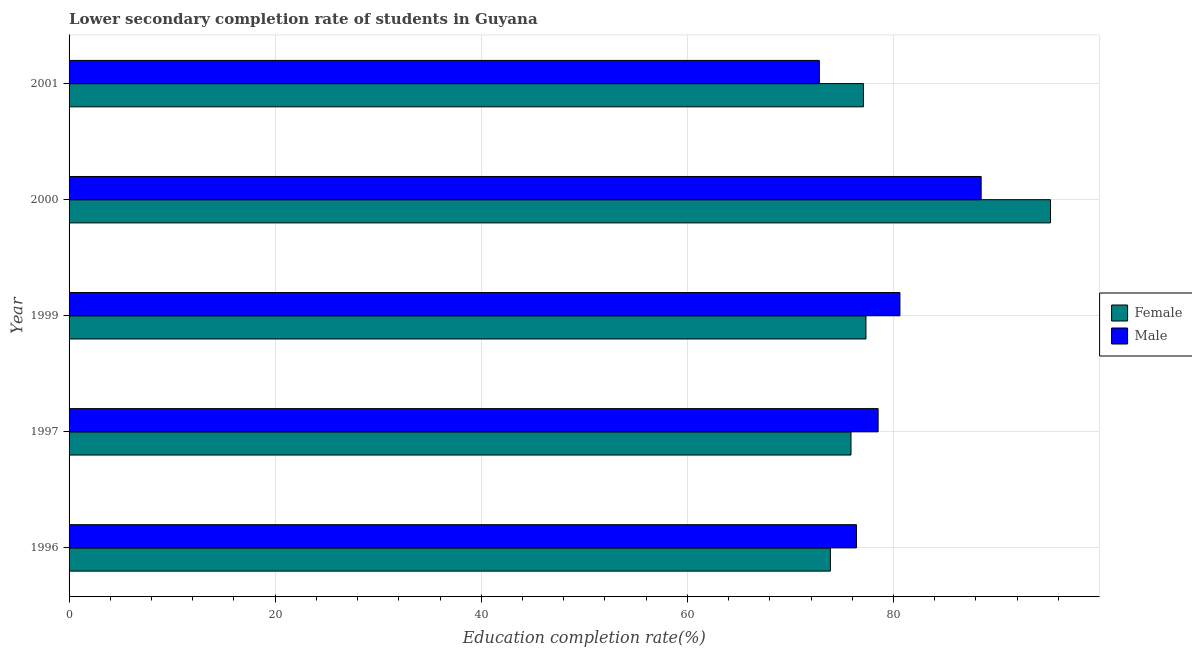How many groups of bars are there?
Offer a terse response. 5. Are the number of bars per tick equal to the number of legend labels?
Keep it short and to the point. Yes. In how many cases, is the number of bars for a given year not equal to the number of legend labels?
Your response must be concise. 0. What is the education completion rate of male students in 2001?
Keep it short and to the point. 72.8. Across all years, what is the maximum education completion rate of female students?
Make the answer very short. 95.24. Across all years, what is the minimum education completion rate of female students?
Your answer should be very brief. 73.87. In which year was the education completion rate of male students maximum?
Offer a very short reply. 2000. In which year was the education completion rate of female students minimum?
Offer a very short reply. 1996. What is the total education completion rate of male students in the graph?
Ensure brevity in your answer.  396.84. What is the difference between the education completion rate of male students in 1997 and that in 2000?
Provide a succinct answer. -10. What is the difference between the education completion rate of female students in 1996 and the education completion rate of male students in 1999?
Offer a very short reply. -6.75. What is the average education completion rate of female students per year?
Your answer should be compact. 79.88. In the year 2000, what is the difference between the education completion rate of female students and education completion rate of male students?
Ensure brevity in your answer.  6.73. What is the ratio of the education completion rate of male students in 1997 to that in 1999?
Your answer should be compact. 0.97. Is the education completion rate of female students in 1996 less than that in 2000?
Your response must be concise. Yes. Is the difference between the education completion rate of male students in 1996 and 2001 greater than the difference between the education completion rate of female students in 1996 and 2001?
Make the answer very short. Yes. What is the difference between the highest and the second highest education completion rate of female students?
Give a very brief answer. 17.91. What is the difference between the highest and the lowest education completion rate of female students?
Make the answer very short. 21.36. What does the 1st bar from the bottom in 2000 represents?
Your answer should be very brief. Female. How many bars are there?
Provide a short and direct response. 10. How many years are there in the graph?
Give a very brief answer. 5. Are the values on the major ticks of X-axis written in scientific E-notation?
Give a very brief answer. No. Does the graph contain any zero values?
Keep it short and to the point. No. How are the legend labels stacked?
Offer a terse response. Vertical. What is the title of the graph?
Give a very brief answer. Lower secondary completion rate of students in Guyana. What is the label or title of the X-axis?
Provide a succinct answer. Education completion rate(%). What is the Education completion rate(%) in Female in 1996?
Ensure brevity in your answer.  73.87. What is the Education completion rate(%) in Male in 1996?
Keep it short and to the point. 76.4. What is the Education completion rate(%) in Female in 1997?
Give a very brief answer. 75.88. What is the Education completion rate(%) in Male in 1997?
Your response must be concise. 78.51. What is the Education completion rate(%) of Female in 1999?
Your response must be concise. 77.33. What is the Education completion rate(%) in Male in 1999?
Provide a short and direct response. 80.62. What is the Education completion rate(%) of Female in 2000?
Your answer should be very brief. 95.24. What is the Education completion rate(%) of Male in 2000?
Provide a succinct answer. 88.5. What is the Education completion rate(%) in Female in 2001?
Ensure brevity in your answer.  77.08. What is the Education completion rate(%) of Male in 2001?
Provide a short and direct response. 72.8. Across all years, what is the maximum Education completion rate(%) of Female?
Your answer should be very brief. 95.24. Across all years, what is the maximum Education completion rate(%) of Male?
Provide a short and direct response. 88.5. Across all years, what is the minimum Education completion rate(%) of Female?
Your answer should be compact. 73.87. Across all years, what is the minimum Education completion rate(%) in Male?
Your answer should be very brief. 72.8. What is the total Education completion rate(%) of Female in the graph?
Your answer should be very brief. 399.39. What is the total Education completion rate(%) of Male in the graph?
Your answer should be compact. 396.84. What is the difference between the Education completion rate(%) of Female in 1996 and that in 1997?
Your answer should be very brief. -2. What is the difference between the Education completion rate(%) of Male in 1996 and that in 1997?
Make the answer very short. -2.1. What is the difference between the Education completion rate(%) of Female in 1996 and that in 1999?
Ensure brevity in your answer.  -3.45. What is the difference between the Education completion rate(%) in Male in 1996 and that in 1999?
Offer a terse response. -4.22. What is the difference between the Education completion rate(%) in Female in 1996 and that in 2000?
Provide a succinct answer. -21.36. What is the difference between the Education completion rate(%) in Male in 1996 and that in 2000?
Make the answer very short. -12.1. What is the difference between the Education completion rate(%) in Female in 1996 and that in 2001?
Your answer should be very brief. -3.21. What is the difference between the Education completion rate(%) in Male in 1996 and that in 2001?
Keep it short and to the point. 3.6. What is the difference between the Education completion rate(%) of Female in 1997 and that in 1999?
Offer a very short reply. -1.45. What is the difference between the Education completion rate(%) of Male in 1997 and that in 1999?
Your answer should be compact. -2.12. What is the difference between the Education completion rate(%) of Female in 1997 and that in 2000?
Give a very brief answer. -19.36. What is the difference between the Education completion rate(%) of Male in 1997 and that in 2000?
Your response must be concise. -10. What is the difference between the Education completion rate(%) of Female in 1997 and that in 2001?
Ensure brevity in your answer.  -1.2. What is the difference between the Education completion rate(%) in Male in 1997 and that in 2001?
Offer a terse response. 5.7. What is the difference between the Education completion rate(%) of Female in 1999 and that in 2000?
Provide a succinct answer. -17.91. What is the difference between the Education completion rate(%) of Male in 1999 and that in 2000?
Your response must be concise. -7.88. What is the difference between the Education completion rate(%) in Female in 1999 and that in 2001?
Your answer should be very brief. 0.25. What is the difference between the Education completion rate(%) in Male in 1999 and that in 2001?
Keep it short and to the point. 7.82. What is the difference between the Education completion rate(%) in Female in 2000 and that in 2001?
Ensure brevity in your answer.  18.16. What is the difference between the Education completion rate(%) in Male in 2000 and that in 2001?
Your answer should be compact. 15.7. What is the difference between the Education completion rate(%) in Female in 1996 and the Education completion rate(%) in Male in 1997?
Your response must be concise. -4.63. What is the difference between the Education completion rate(%) of Female in 1996 and the Education completion rate(%) of Male in 1999?
Make the answer very short. -6.75. What is the difference between the Education completion rate(%) of Female in 1996 and the Education completion rate(%) of Male in 2000?
Provide a short and direct response. -14.63. What is the difference between the Education completion rate(%) in Female in 1996 and the Education completion rate(%) in Male in 2001?
Your answer should be very brief. 1.07. What is the difference between the Education completion rate(%) of Female in 1997 and the Education completion rate(%) of Male in 1999?
Keep it short and to the point. -4.75. What is the difference between the Education completion rate(%) in Female in 1997 and the Education completion rate(%) in Male in 2000?
Make the answer very short. -12.63. What is the difference between the Education completion rate(%) of Female in 1997 and the Education completion rate(%) of Male in 2001?
Your answer should be very brief. 3.07. What is the difference between the Education completion rate(%) in Female in 1999 and the Education completion rate(%) in Male in 2000?
Keep it short and to the point. -11.18. What is the difference between the Education completion rate(%) of Female in 1999 and the Education completion rate(%) of Male in 2001?
Provide a short and direct response. 4.52. What is the difference between the Education completion rate(%) in Female in 2000 and the Education completion rate(%) in Male in 2001?
Provide a short and direct response. 22.43. What is the average Education completion rate(%) of Female per year?
Ensure brevity in your answer.  79.88. What is the average Education completion rate(%) of Male per year?
Your answer should be compact. 79.37. In the year 1996, what is the difference between the Education completion rate(%) in Female and Education completion rate(%) in Male?
Ensure brevity in your answer.  -2.53. In the year 1997, what is the difference between the Education completion rate(%) in Female and Education completion rate(%) in Male?
Give a very brief answer. -2.63. In the year 1999, what is the difference between the Education completion rate(%) in Female and Education completion rate(%) in Male?
Keep it short and to the point. -3.3. In the year 2000, what is the difference between the Education completion rate(%) of Female and Education completion rate(%) of Male?
Your answer should be compact. 6.73. In the year 2001, what is the difference between the Education completion rate(%) in Female and Education completion rate(%) in Male?
Keep it short and to the point. 4.28. What is the ratio of the Education completion rate(%) of Female in 1996 to that in 1997?
Keep it short and to the point. 0.97. What is the ratio of the Education completion rate(%) in Male in 1996 to that in 1997?
Ensure brevity in your answer.  0.97. What is the ratio of the Education completion rate(%) in Female in 1996 to that in 1999?
Provide a succinct answer. 0.96. What is the ratio of the Education completion rate(%) in Male in 1996 to that in 1999?
Your answer should be very brief. 0.95. What is the ratio of the Education completion rate(%) of Female in 1996 to that in 2000?
Your response must be concise. 0.78. What is the ratio of the Education completion rate(%) in Male in 1996 to that in 2000?
Make the answer very short. 0.86. What is the ratio of the Education completion rate(%) in Female in 1996 to that in 2001?
Your answer should be compact. 0.96. What is the ratio of the Education completion rate(%) in Male in 1996 to that in 2001?
Keep it short and to the point. 1.05. What is the ratio of the Education completion rate(%) of Female in 1997 to that in 1999?
Ensure brevity in your answer.  0.98. What is the ratio of the Education completion rate(%) of Male in 1997 to that in 1999?
Your response must be concise. 0.97. What is the ratio of the Education completion rate(%) in Female in 1997 to that in 2000?
Your answer should be very brief. 0.8. What is the ratio of the Education completion rate(%) in Male in 1997 to that in 2000?
Make the answer very short. 0.89. What is the ratio of the Education completion rate(%) in Female in 1997 to that in 2001?
Offer a very short reply. 0.98. What is the ratio of the Education completion rate(%) of Male in 1997 to that in 2001?
Offer a terse response. 1.08. What is the ratio of the Education completion rate(%) of Female in 1999 to that in 2000?
Your answer should be compact. 0.81. What is the ratio of the Education completion rate(%) of Male in 1999 to that in 2000?
Keep it short and to the point. 0.91. What is the ratio of the Education completion rate(%) of Male in 1999 to that in 2001?
Offer a very short reply. 1.11. What is the ratio of the Education completion rate(%) of Female in 2000 to that in 2001?
Ensure brevity in your answer.  1.24. What is the ratio of the Education completion rate(%) of Male in 2000 to that in 2001?
Your answer should be very brief. 1.22. What is the difference between the highest and the second highest Education completion rate(%) in Female?
Provide a short and direct response. 17.91. What is the difference between the highest and the second highest Education completion rate(%) in Male?
Give a very brief answer. 7.88. What is the difference between the highest and the lowest Education completion rate(%) in Female?
Your response must be concise. 21.36. What is the difference between the highest and the lowest Education completion rate(%) of Male?
Make the answer very short. 15.7. 